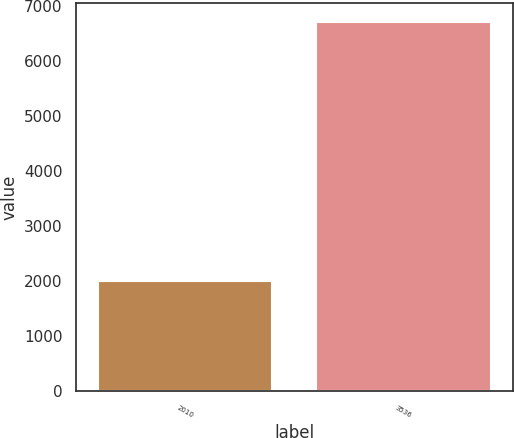Convert chart. <chart><loc_0><loc_0><loc_500><loc_500><bar_chart><fcel>2010<fcel>3536<nl><fcel>2009<fcel>6711<nl></chart> 